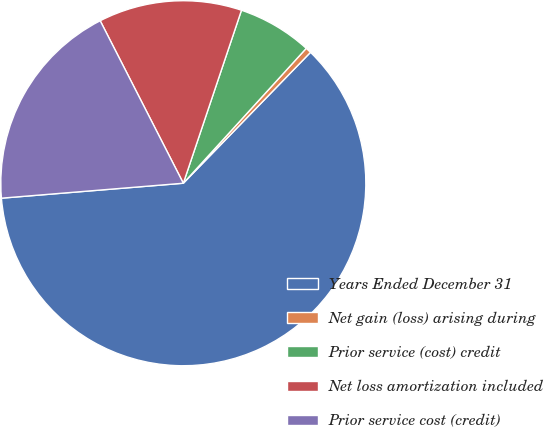Convert chart. <chart><loc_0><loc_0><loc_500><loc_500><pie_chart><fcel>Years Ended December 31<fcel>Net gain (loss) arising during<fcel>Prior service (cost) credit<fcel>Net loss amortization included<fcel>Prior service cost (credit)<nl><fcel>61.43%<fcel>0.51%<fcel>6.6%<fcel>12.69%<fcel>18.78%<nl></chart> 